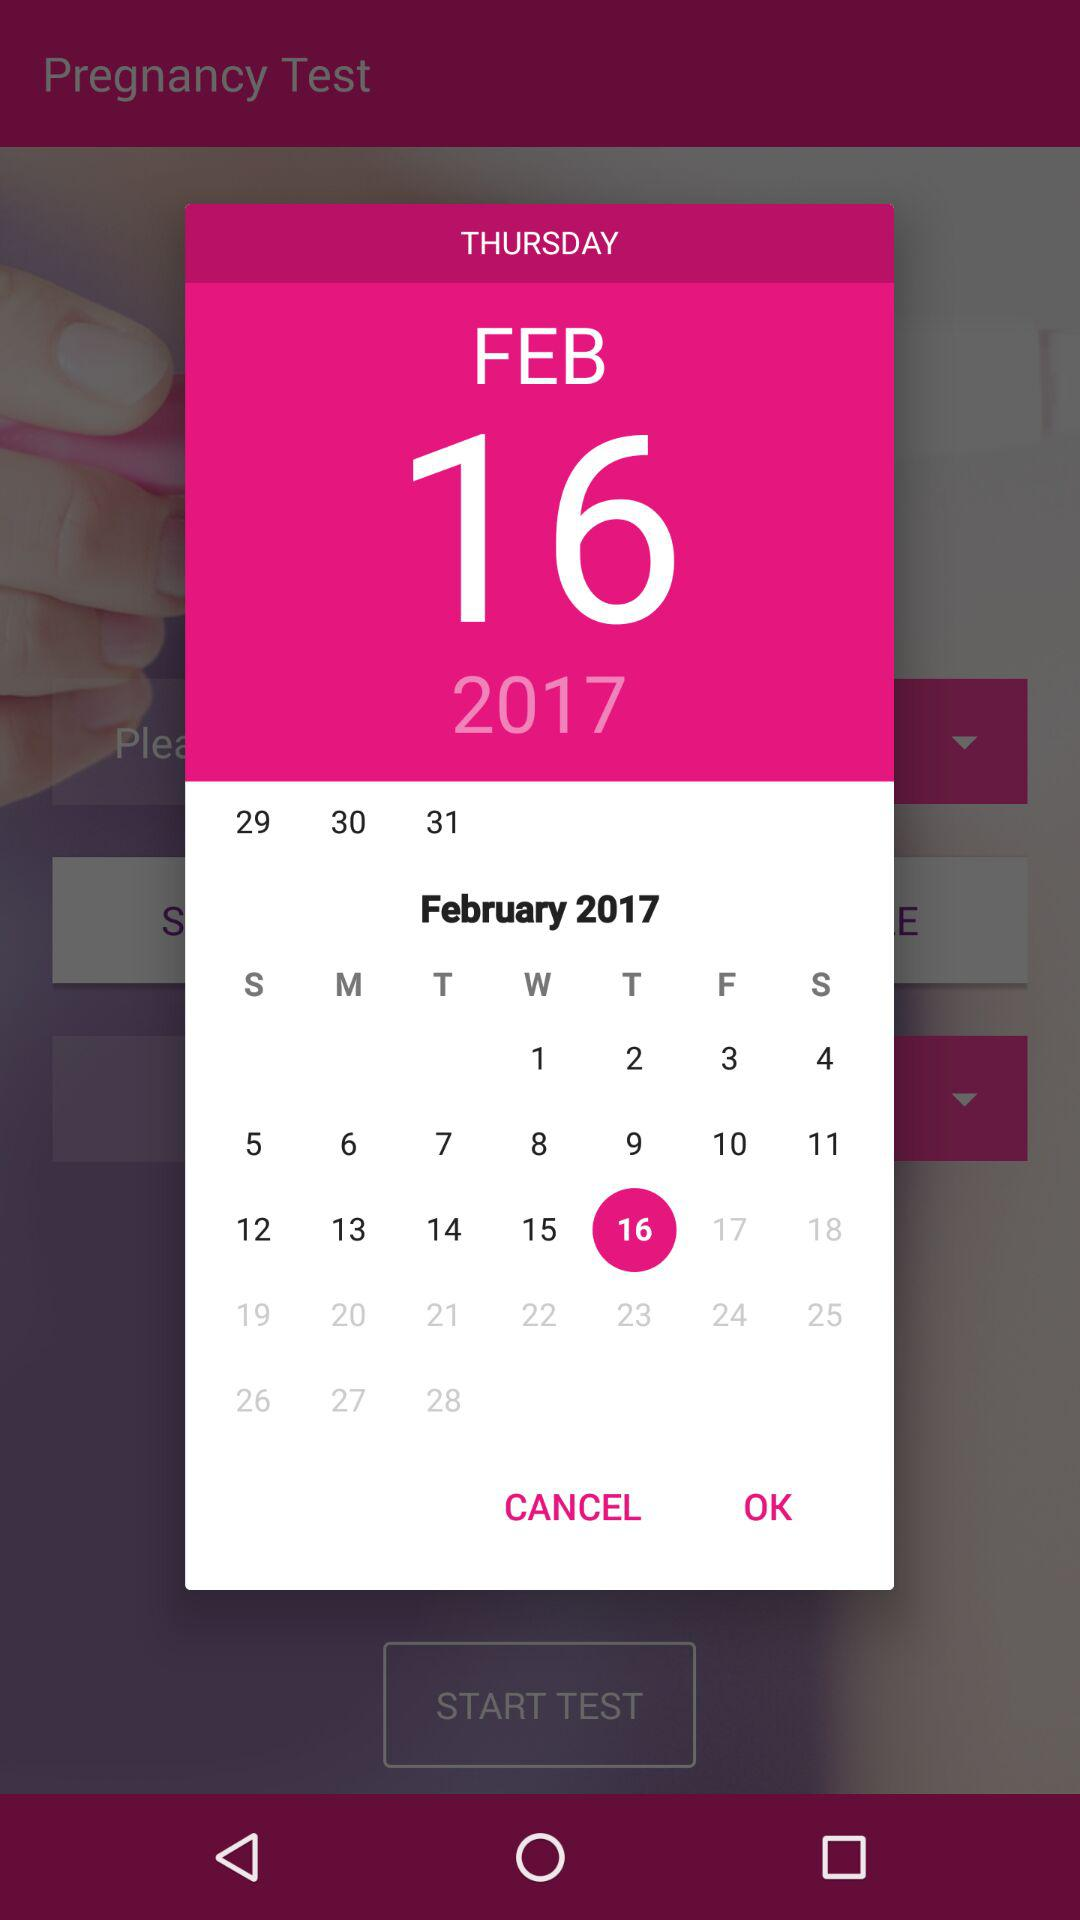Which day was February 16, 2017? The day was Thursday. 